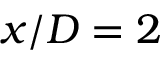<formula> <loc_0><loc_0><loc_500><loc_500>x / D = 2</formula> 